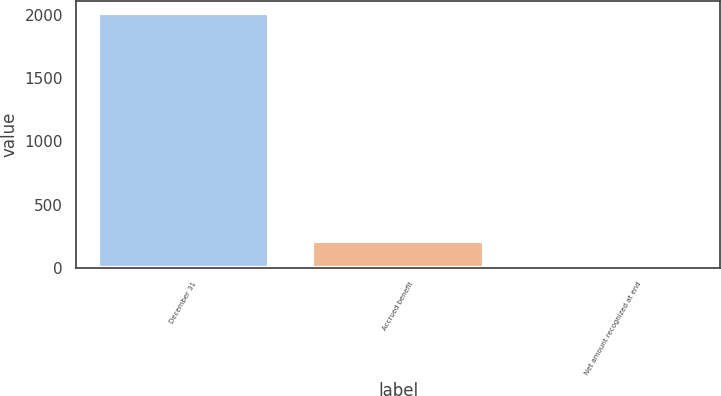Convert chart to OTSL. <chart><loc_0><loc_0><loc_500><loc_500><bar_chart><fcel>December 31<fcel>Accrued benefit<fcel>Net amount recognized at end<nl><fcel>2016<fcel>209.7<fcel>9<nl></chart> 